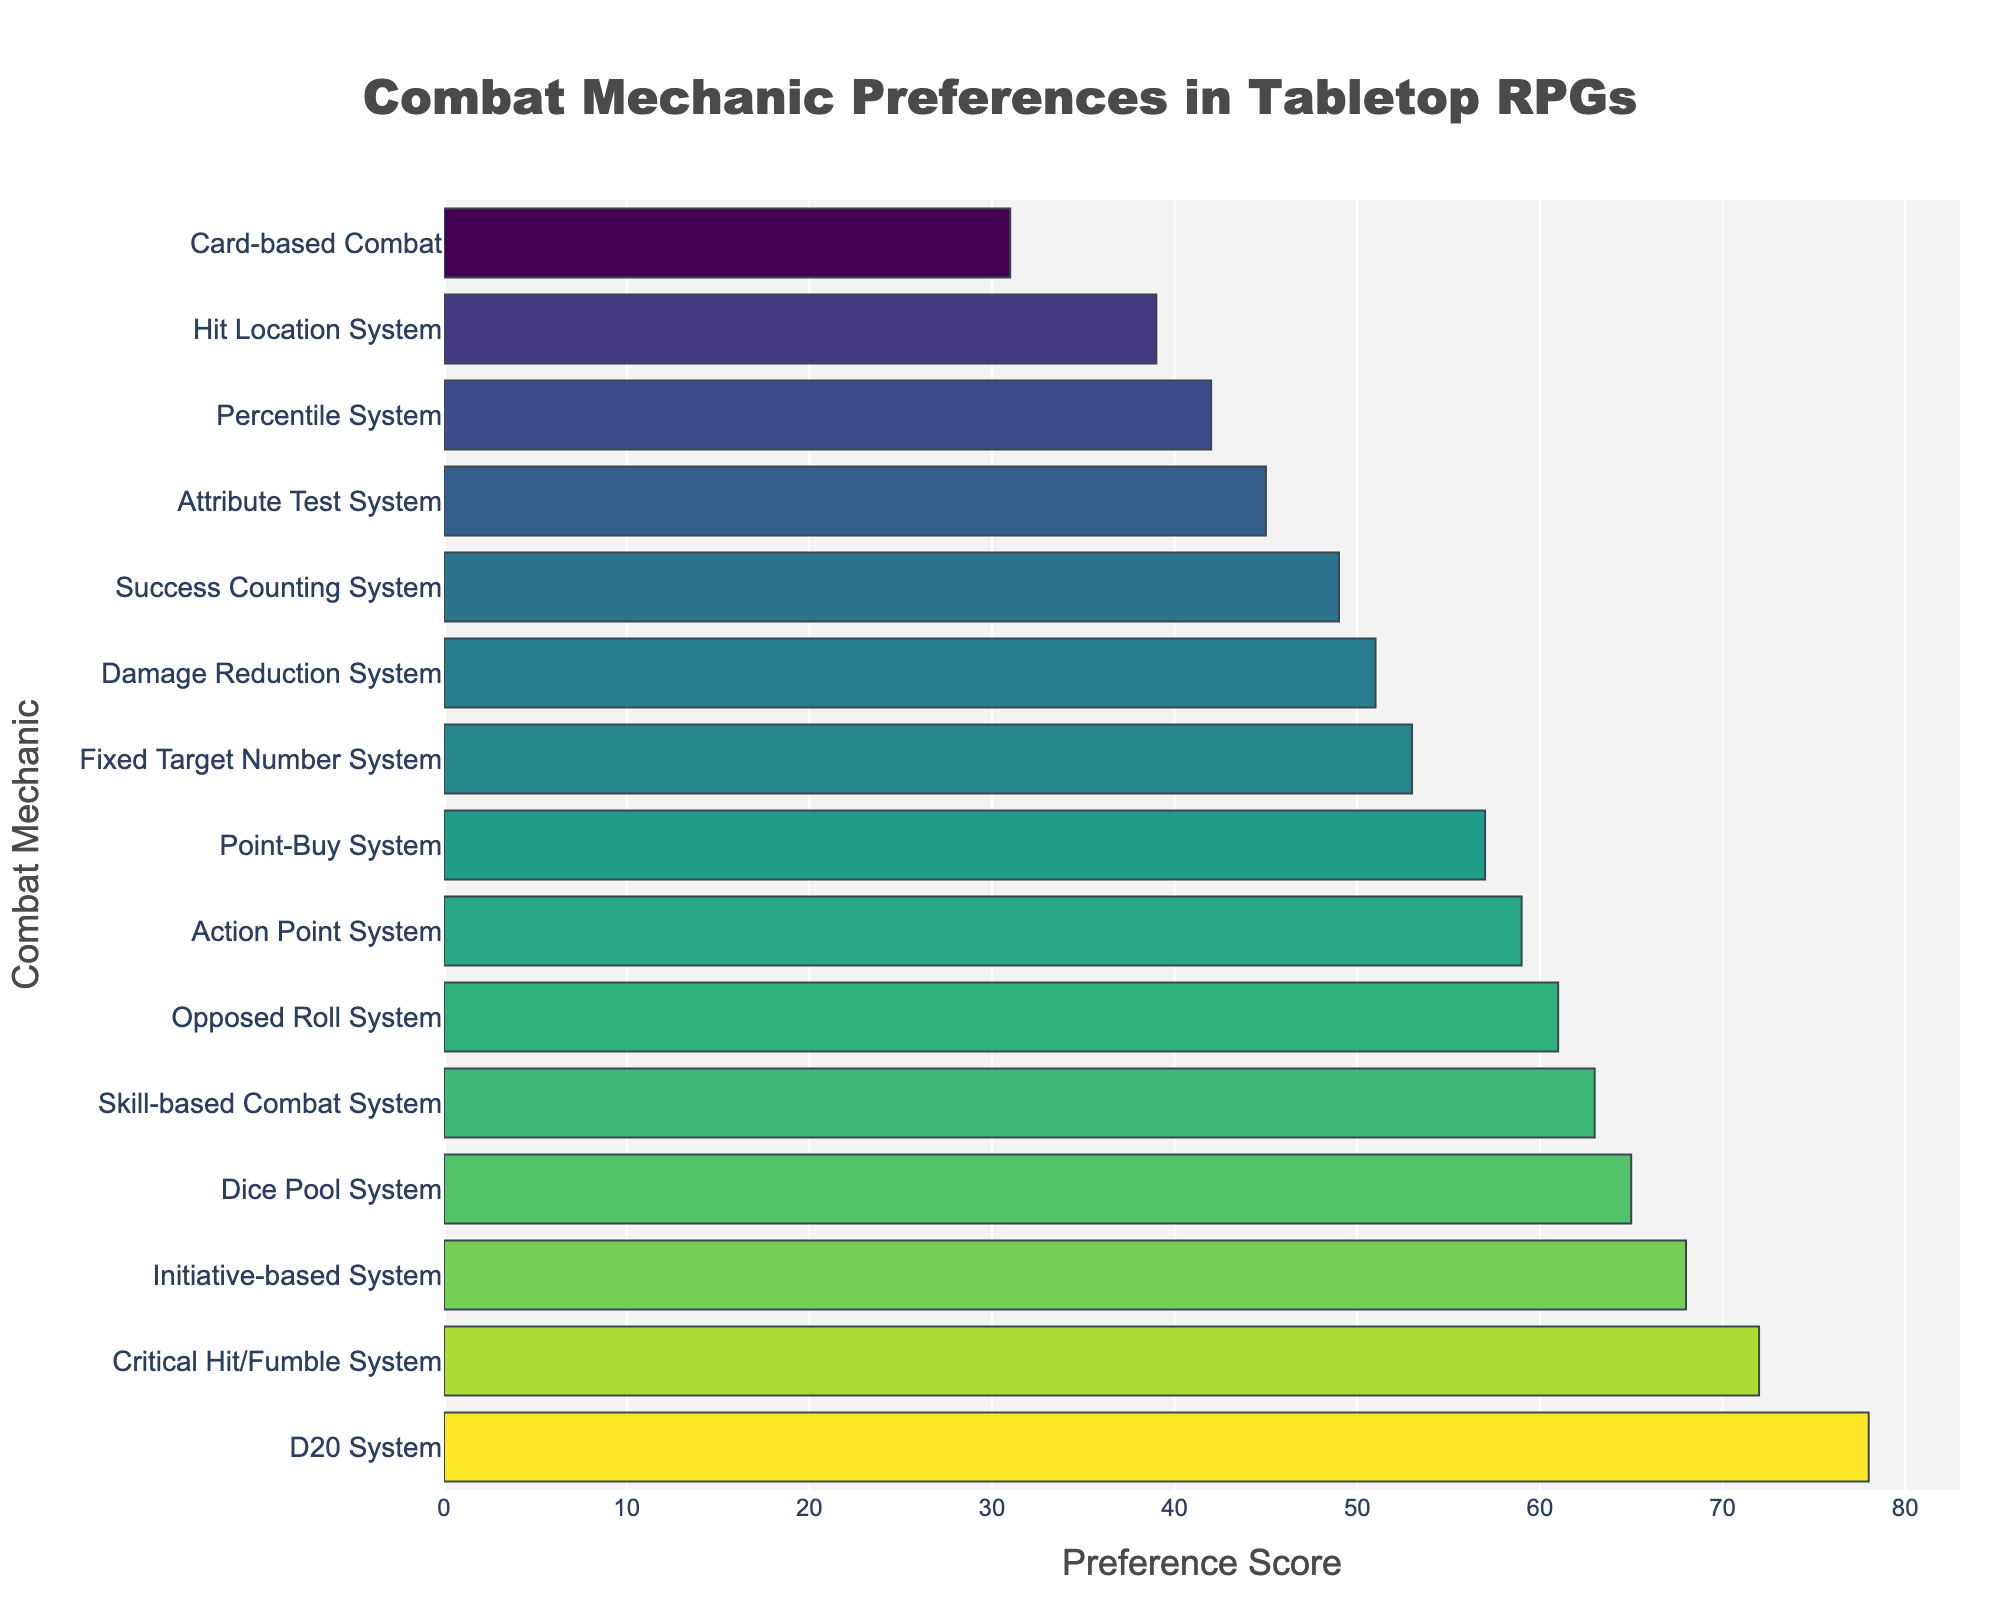Which combat mechanic has the highest preference score? The bar representing the D20 System is the tallest and positioned at the top, indicating it has the highest preference score.
Answer: D20 System Which combat mechanics have a preference score greater than 60? The bars indicating a preference score greater than 60 include the D20 System, Critical Hit/Fumble System, Initiative-based System, and Dice Pool System.
Answer: D20 System, Critical Hit/Fumble System, Initiative-based System, Dice Pool System What is the total preference score for systems based on die rolls (D20 System, Dice Pool System, Percentile System, and Fixed Target Number System)? Add the preference scores of the D20 System (78), Dice Pool System (65), Percentile System (42), and Fixed Target Number System (53): 78 + 65 + 42 + 53 = 238.
Answer: 238 Compare the preference scores of the Success Counting System and the Attribute Test System. Which one is higher, and by how much? The preference score for the Success Counting System is 49, and for the Attribute Test System, it is 45. The Success Counting System has a higher score by 49 - 45 = 4.
Answer: Success Counting System, 4 Which combat mechanic ranks third in terms of preference score? The bar representing the Critical Hit/Fumble System is third from the top, indicating it ranks third in terms of preference score.
Answer: Critical Hit/Fumble System What is the difference in preference scores between the Skill-based Combat System and the Hit Location System? The preference score for the Skill-based Combat System is 63 and for the Hit Location System, it is 39. The difference is 63 - 39 = 24.
Answer: 24 Calculate the average preference score of the Combat Mechanics listed. Sum all preference scores: 78 + 65 + 42 + 31 + 57 + 49 + 61 + 53 + 45 + 39 + 72 + 68 + 59 + 51 + 63 = 833. There are 15 combat mechanics, so the average is 833 / 15 = 55.53.
Answer: 55.53 Which combat mechanics have preference scores between 50 and 70? The bars indicating preference scores between 50 and 70 are Action Point System (59), Skill-based Combat System (63), Damage Reduction System (51), Opposed Roll System (61), Point-Buy System (57), and Initiative-based System (68).
Answer: Action Point System, Skill-based Combat System, Damage Reduction System, Opposed Roll System, Point-Buy System, Initiative-based System 